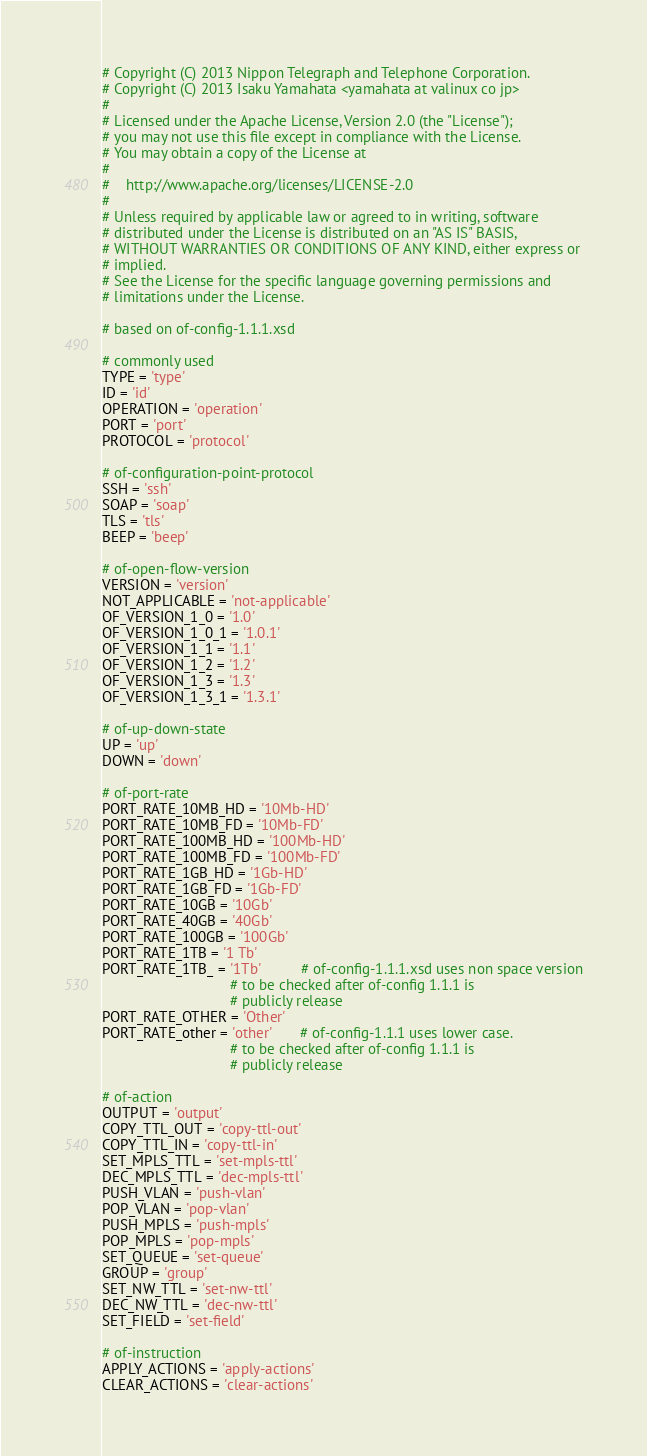<code> <loc_0><loc_0><loc_500><loc_500><_Python_># Copyright (C) 2013 Nippon Telegraph and Telephone Corporation.
# Copyright (C) 2013 Isaku Yamahata <yamahata at valinux co jp>
#
# Licensed under the Apache License, Version 2.0 (the "License");
# you may not use this file except in compliance with the License.
# You may obtain a copy of the License at
#
#    http://www.apache.org/licenses/LICENSE-2.0
#
# Unless required by applicable law or agreed to in writing, software
# distributed under the License is distributed on an "AS IS" BASIS,
# WITHOUT WARRANTIES OR CONDITIONS OF ANY KIND, either express or
# implied.
# See the License for the specific language governing permissions and
# limitations under the License.

# based on of-config-1.1.1.xsd

# commonly used
TYPE = 'type'
ID = 'id'
OPERATION = 'operation'
PORT = 'port'
PROTOCOL = 'protocol'

# of-configuration-point-protocol
SSH = 'ssh'
SOAP = 'soap'
TLS = 'tls'
BEEP = 'beep'

# of-open-flow-version
VERSION = 'version'
NOT_APPLICABLE = 'not-applicable'
OF_VERSION_1_0 = '1.0'
OF_VERSION_1_0_1 = '1.0.1'
OF_VERSION_1_1 = '1.1'
OF_VERSION_1_2 = '1.2'
OF_VERSION_1_3 = '1.3'
OF_VERSION_1_3_1 = '1.3.1'

# of-up-down-state
UP = 'up'
DOWN = 'down'

# of-port-rate
PORT_RATE_10MB_HD = '10Mb-HD'
PORT_RATE_10MB_FD = '10Mb-FD'
PORT_RATE_100MB_HD = '100Mb-HD'
PORT_RATE_100MB_FD = '100Mb-FD'
PORT_RATE_1GB_HD = '1Gb-HD'
PORT_RATE_1GB_FD = '1Gb-FD'
PORT_RATE_10GB = '10Gb'
PORT_RATE_40GB = '40Gb'
PORT_RATE_100GB = '100Gb'
PORT_RATE_1TB = '1 Tb'
PORT_RATE_1TB_ = '1Tb'          # of-config-1.1.1.xsd uses non space version
                                # to be checked after of-config 1.1.1 is
                                # publicly release
PORT_RATE_OTHER = 'Other'
PORT_RATE_other = 'other'       # of-config-1.1.1 uses lower case.
                                # to be checked after of-config 1.1.1 is
                                # publicly release

# of-action
OUTPUT = 'output'
COPY_TTL_OUT = 'copy-ttl-out'
COPY_TTL_IN = 'copy-ttl-in'
SET_MPLS_TTL = 'set-mpls-ttl'
DEC_MPLS_TTL = 'dec-mpls-ttl'
PUSH_VLAN = 'push-vlan'
POP_VLAN = 'pop-vlan'
PUSH_MPLS = 'push-mpls'
POP_MPLS = 'pop-mpls'
SET_QUEUE = 'set-queue'
GROUP = 'group'
SET_NW_TTL = 'set-nw-ttl'
DEC_NW_TTL = 'dec-nw-ttl'
SET_FIELD = 'set-field'

# of-instruction
APPLY_ACTIONS = 'apply-actions'
CLEAR_ACTIONS = 'clear-actions'</code> 